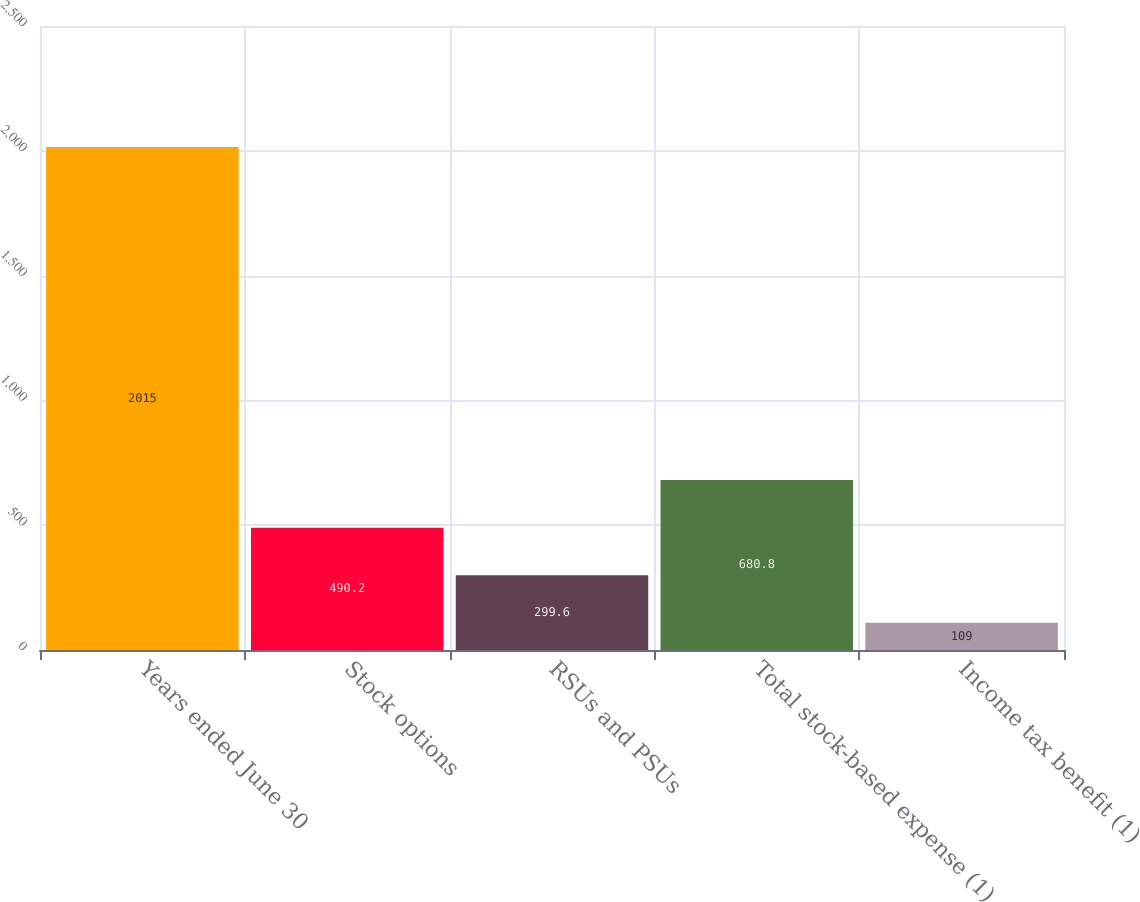Convert chart. <chart><loc_0><loc_0><loc_500><loc_500><bar_chart><fcel>Years ended June 30<fcel>Stock options<fcel>RSUs and PSUs<fcel>Total stock-based expense (1)<fcel>Income tax benefit (1)<nl><fcel>2015<fcel>490.2<fcel>299.6<fcel>680.8<fcel>109<nl></chart> 